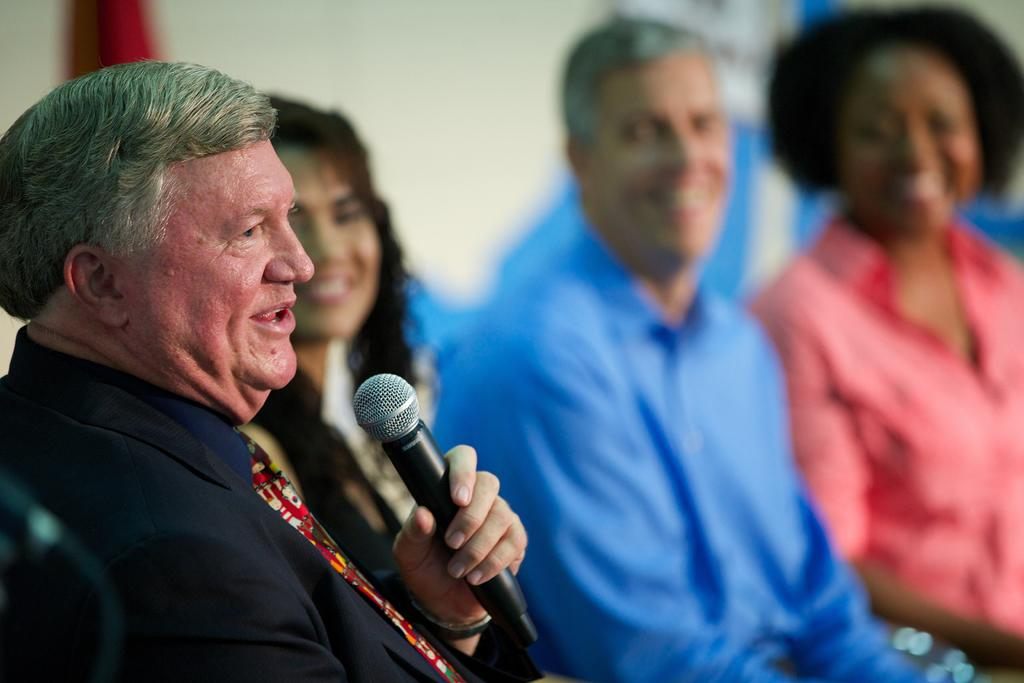What is the man in the image doing? The man is sitting in the image and holding a microphone. What might the man be doing with the microphone? The man is talking, which suggests he might be using the microphone for speaking or singing. Can you describe the people in the background of the image? There are two women and a man sitting in the background. What type of building can be seen in the image? There is no building present in the image; it features a man sitting with a microphone and people in the background. What recess activity is the man participating in with the microphone? There is no recess activity depicted in the image, as it does not take place in a school or educational setting. 